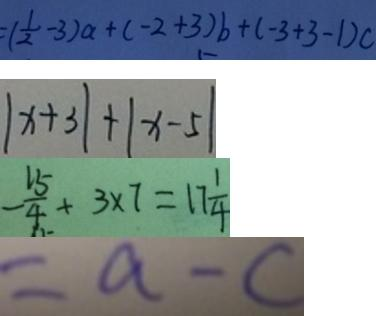Convert formula to latex. <formula><loc_0><loc_0><loc_500><loc_500>= ( \frac { 1 } { 2 } - 3 ) a + ( - 2 + 3 ) b + ( - 3 + 3 - 1 ) c 
 \vert x + 3 \vert + \vert x - 5 \vert 
 - \frac { 1 5 } { 4 } + 3 \times 7 = 1 7 \frac { 1 } { 4 } 
 = a - c</formula> 